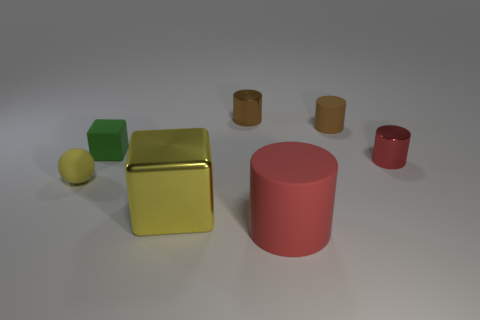Add 1 yellow shiny blocks. How many objects exist? 8 Subtract all cubes. How many objects are left? 5 Add 3 brown rubber objects. How many brown rubber objects are left? 4 Add 6 small cylinders. How many small cylinders exist? 9 Subtract 0 purple cylinders. How many objects are left? 7 Subtract all small yellow rubber things. Subtract all brown shiny things. How many objects are left? 5 